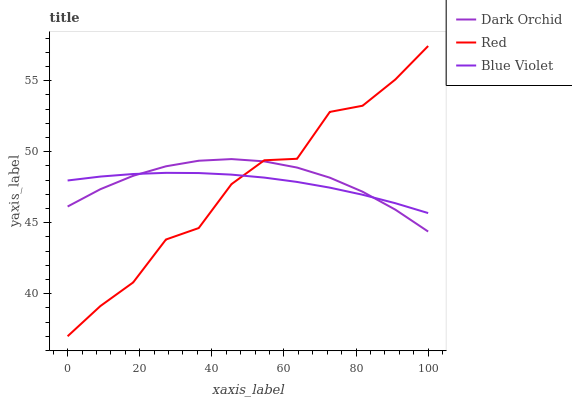Does Red have the minimum area under the curve?
Answer yes or no. Yes. Does Dark Orchid have the maximum area under the curve?
Answer yes or no. Yes. Does Dark Orchid have the minimum area under the curve?
Answer yes or no. No. Does Red have the maximum area under the curve?
Answer yes or no. No. Is Blue Violet the smoothest?
Answer yes or no. Yes. Is Red the roughest?
Answer yes or no. Yes. Is Dark Orchid the smoothest?
Answer yes or no. No. Is Dark Orchid the roughest?
Answer yes or no. No. Does Dark Orchid have the lowest value?
Answer yes or no. No. Does Red have the highest value?
Answer yes or no. Yes. Does Dark Orchid have the highest value?
Answer yes or no. No. Does Red intersect Dark Orchid?
Answer yes or no. Yes. Is Red less than Dark Orchid?
Answer yes or no. No. Is Red greater than Dark Orchid?
Answer yes or no. No. 